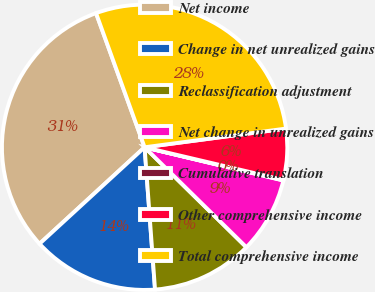Convert chart to OTSL. <chart><loc_0><loc_0><loc_500><loc_500><pie_chart><fcel>Net income<fcel>Change in net unrealized gains<fcel>Reclassification adjustment<fcel>Net change in unrealized gains<fcel>Cumulative translation<fcel>Other comprehensive income<fcel>Total comprehensive income<nl><fcel>31.3%<fcel>14.34%<fcel>11.48%<fcel>8.62%<fcel>0.06%<fcel>5.77%<fcel>28.44%<nl></chart> 